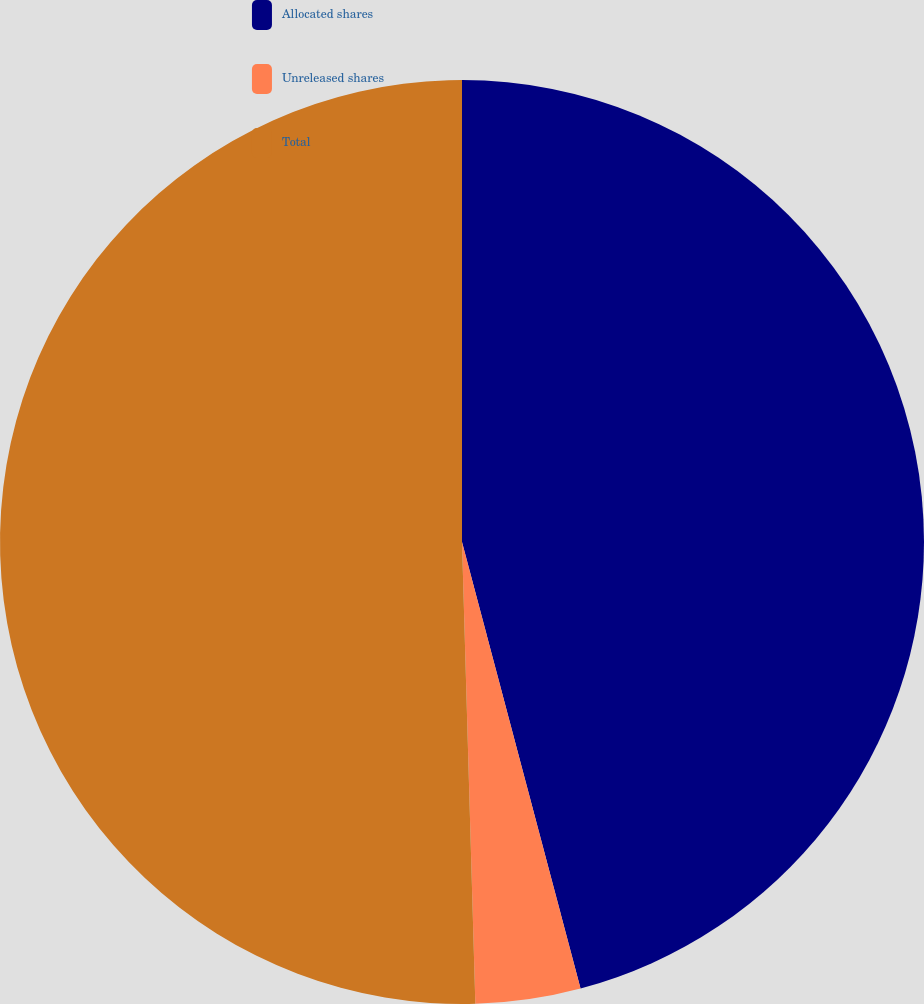<chart> <loc_0><loc_0><loc_500><loc_500><pie_chart><fcel>Allocated shares<fcel>Unreleased shares<fcel>Total<nl><fcel>45.87%<fcel>3.67%<fcel>50.46%<nl></chart> 